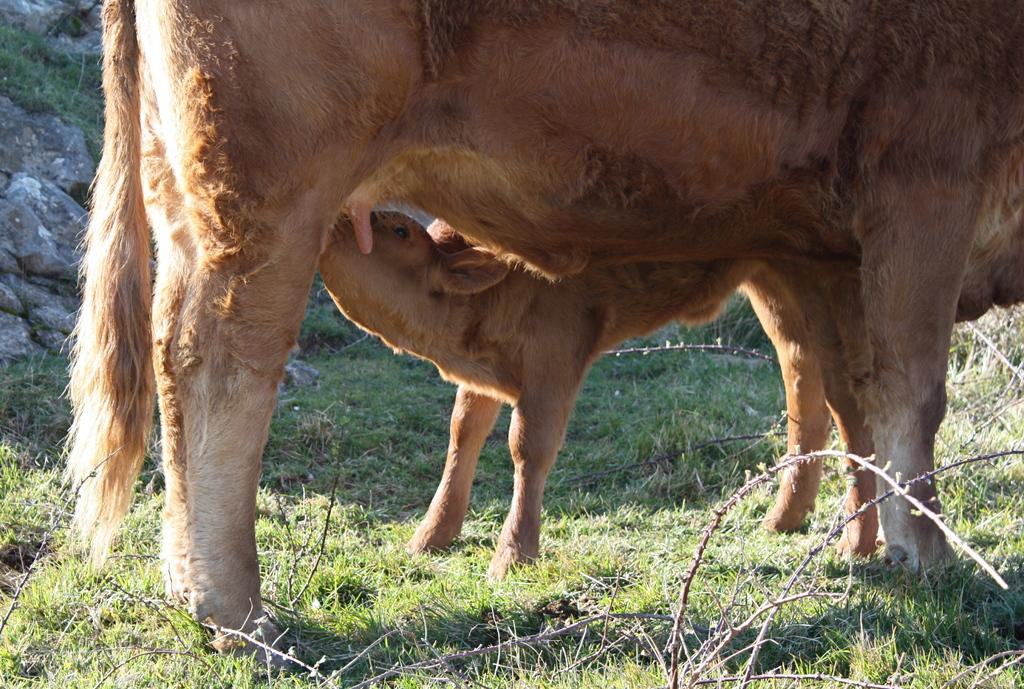What is located in the center of the image? There are two animals in the center of the image. What can be seen in the background of the image? There are rocks in the background of the image. What type of vegetation is at the bottom of the image? There is grass at the bottom of the image. What else is present at the bottom of the image besides grass? There are sticks at the bottom of the image. What type of wrench is being used by the animals in the image? There is no wrench present in the image; it features two animals, rocks in the background, grass, and sticks at the bottom. Can you tell me how many tickets are visible in the image? There are no tickets present in the image. 